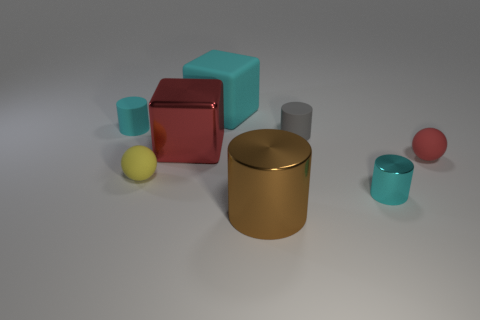What material is the large cyan thing?
Provide a short and direct response. Rubber. The cyan rubber object that is the same size as the brown metallic cylinder is what shape?
Provide a short and direct response. Cube. Are there any metal objects of the same color as the big metal cylinder?
Make the answer very short. No. Is the color of the large shiny block the same as the small rubber cylinder left of the gray cylinder?
Make the answer very short. No. There is a big thing that is behind the small cyan thing on the left side of the shiny cube; what is its color?
Your answer should be very brief. Cyan. Are there any matte blocks that are behind the large thing that is on the right side of the large object that is behind the tiny cyan rubber cylinder?
Give a very brief answer. Yes. There is a large thing that is made of the same material as the tiny red sphere; what is its color?
Your answer should be very brief. Cyan. How many gray cylinders have the same material as the big red object?
Your answer should be very brief. 0. Are the large cylinder and the tiny cyan thing that is behind the tiny red matte object made of the same material?
Your response must be concise. No. What number of objects are tiny spheres that are behind the yellow matte thing or tiny red spheres?
Your answer should be compact. 1. 